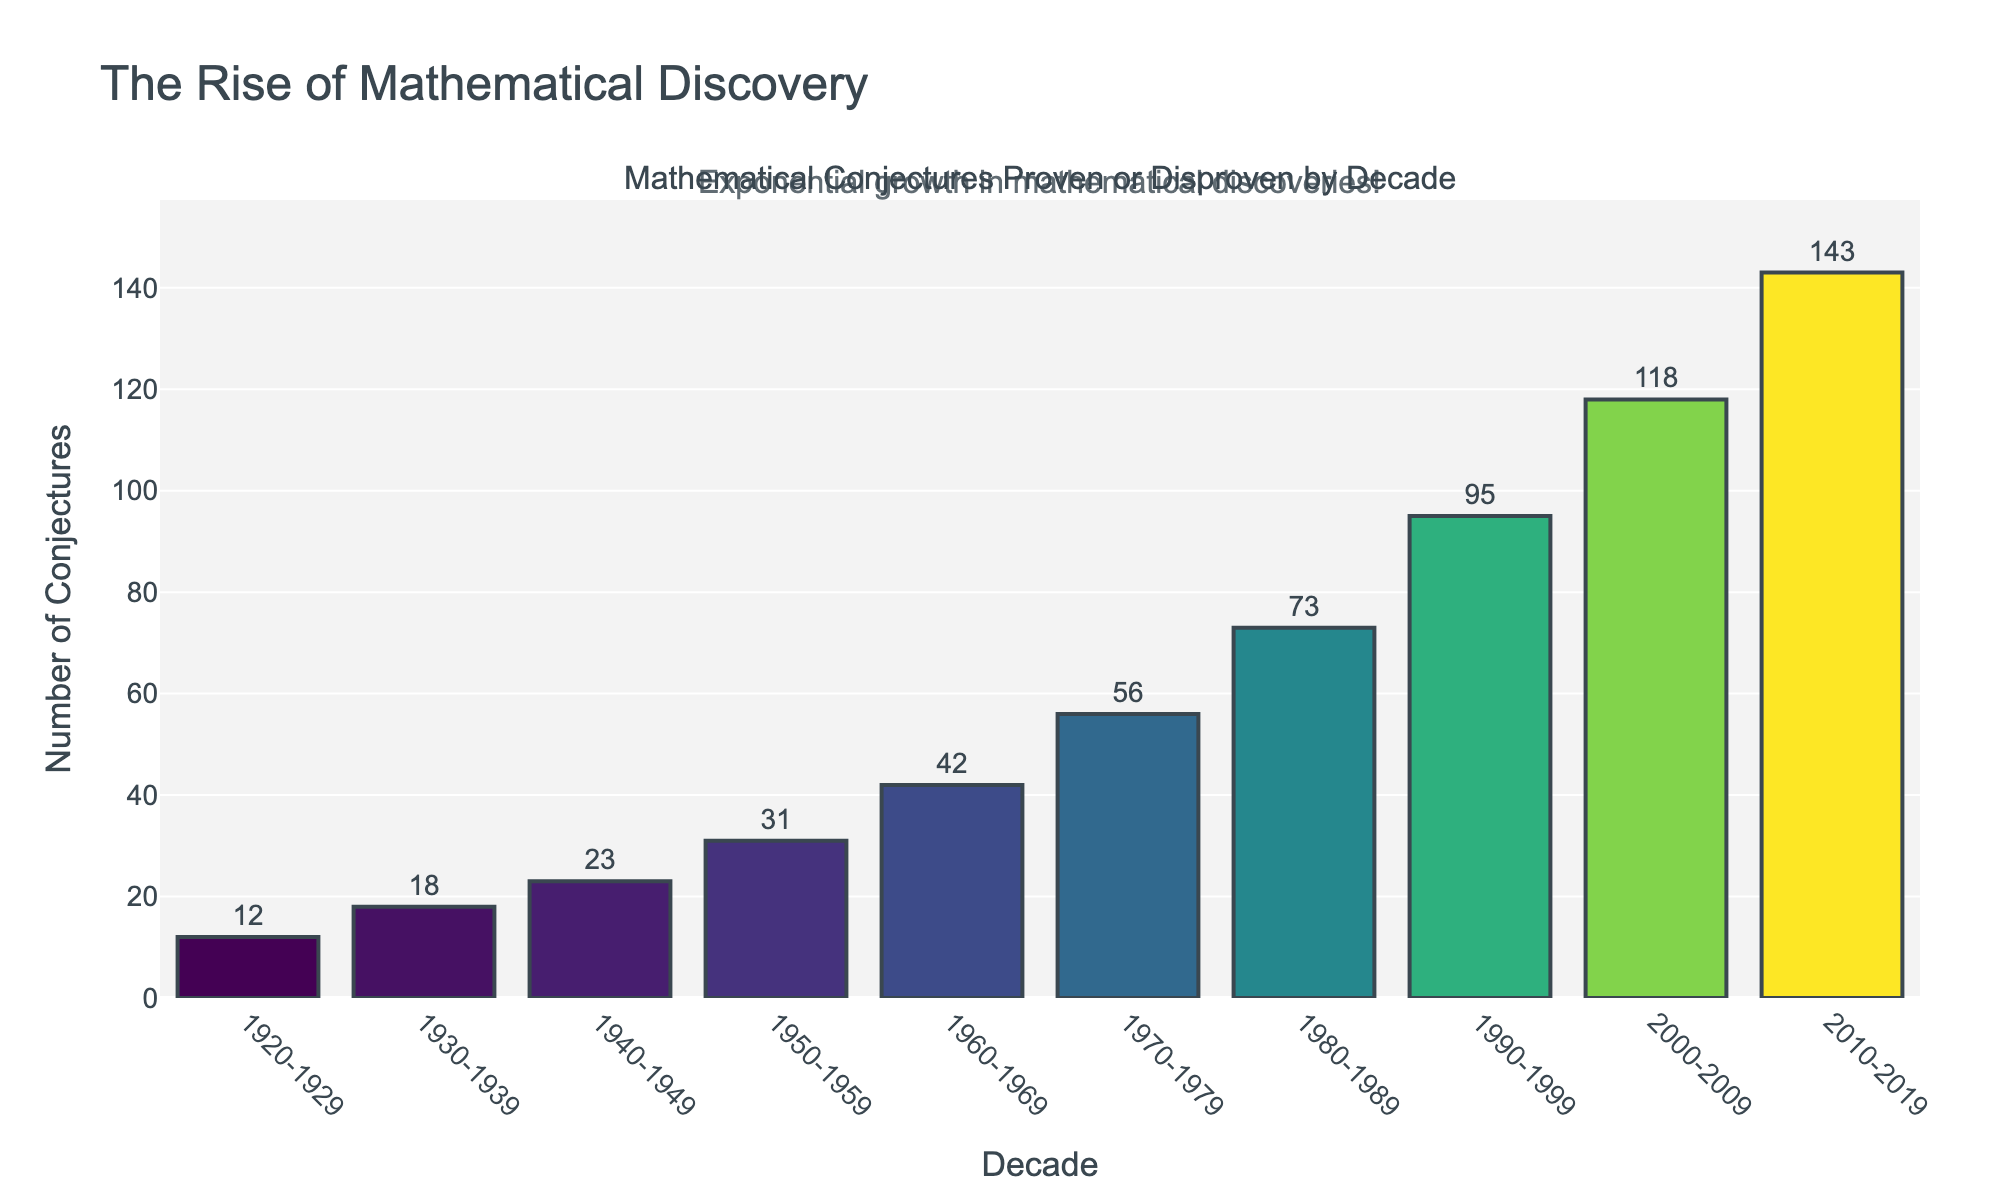What is the total number of conjectures proven or disproven from 1920 to 1939? Sum the conjectures proven or disproven for the decades 1920-1929 and 1930-1939: 12 (1920-1929) + 18 (1930-1939) = 30
Answer: 30 Between which two consecutive decades did the number of proven or disproven conjectures increase the most? Calculate the increase between each pair of consecutive decades and find the pair with the highest increase: (1930s-1920s) = 18-12 = 6, (1940s-1930s) = 23-18 = 5, (1950s-1940s) = 31-23 = 8, (1960s-1950s) = 42-31 = 11, (1970s-1960s) = 56-42 = 14, (1980s-1970s) = 73-56 = 17, (1990s-1980s) = 95-73 = 22, (2000s-1990s) = 118-95 = 23, (2010s-2000s) = 143-118 = 25. The largest increase is between 2000-2009 and 2010-2019 (143-118 = 25)
Answer: 2000-2009 and 2010-2019 How many more conjectures were proven or disproven in the 2010-2019 decade compared to the 1980-1989 decade? Subtract the number from the 1980-1989 decade from the number in the 2010-2019 decade: 143 - 73 = 70
Answer: 70 Which decade had the lowest number of mathematical conjectures proven or disproven? Identify the decade with the smallest value from the bar chart: 1920-1929 with 12 conjectures
Answer: 1920-1929 What is the average number of conjectures proven or disproven per decade between the 1920-1929 and 1990-1999 periods? Sum the values from 1920-1929 to 1990-1999 and divide by 8: (12 + 18 + 23 + 31 + 42 + 56 + 73 + 95) / 8 = 350 / 8 = 43.75
Answer: 43.75 What trend is observed in the number of conjectures proven or disproven over the decades? The number of conjectures proven or disproven increases from the decade 1920-1929 to 2010-2019, showing an exponential growth trend
Answer: Exponential growth In which decade did the number of proven or disproven conjectures first exceed 50? Identify the first decade where the number is greater than 50: 1970-1979 with 56 conjectures
Answer: 1970-1979 What visual element emphasizes the increase in the number of conjectures over time? The bar heights increase and are colored using a gradient (from darker to lighter shades) as the number of conjectures increases
Answer: Bar heights and color gradient 